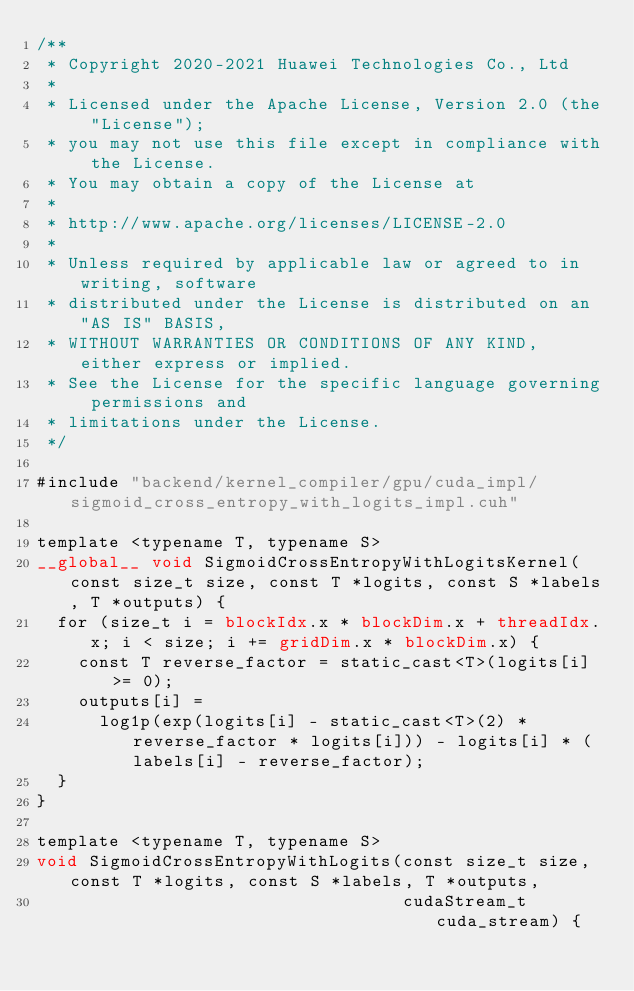<code> <loc_0><loc_0><loc_500><loc_500><_Cuda_>/**
 * Copyright 2020-2021 Huawei Technologies Co., Ltd
 *
 * Licensed under the Apache License, Version 2.0 (the "License");
 * you may not use this file except in compliance with the License.
 * You may obtain a copy of the License at
 *
 * http://www.apache.org/licenses/LICENSE-2.0
 *
 * Unless required by applicable law or agreed to in writing, software
 * distributed under the License is distributed on an "AS IS" BASIS,
 * WITHOUT WARRANTIES OR CONDITIONS OF ANY KIND, either express or implied.
 * See the License for the specific language governing permissions and
 * limitations under the License.
 */

#include "backend/kernel_compiler/gpu/cuda_impl/sigmoid_cross_entropy_with_logits_impl.cuh"

template <typename T, typename S>
__global__ void SigmoidCrossEntropyWithLogitsKernel(const size_t size, const T *logits, const S *labels, T *outputs) {
  for (size_t i = blockIdx.x * blockDim.x + threadIdx.x; i < size; i += gridDim.x * blockDim.x) {
    const T reverse_factor = static_cast<T>(logits[i] >= 0);
    outputs[i] =
      log1p(exp(logits[i] - static_cast<T>(2) * reverse_factor * logits[i])) - logits[i] * (labels[i] - reverse_factor);
  }
}

template <typename T, typename S>
void SigmoidCrossEntropyWithLogits(const size_t size, const T *logits, const S *labels, T *outputs,
                                   cudaStream_t cuda_stream) {</code> 